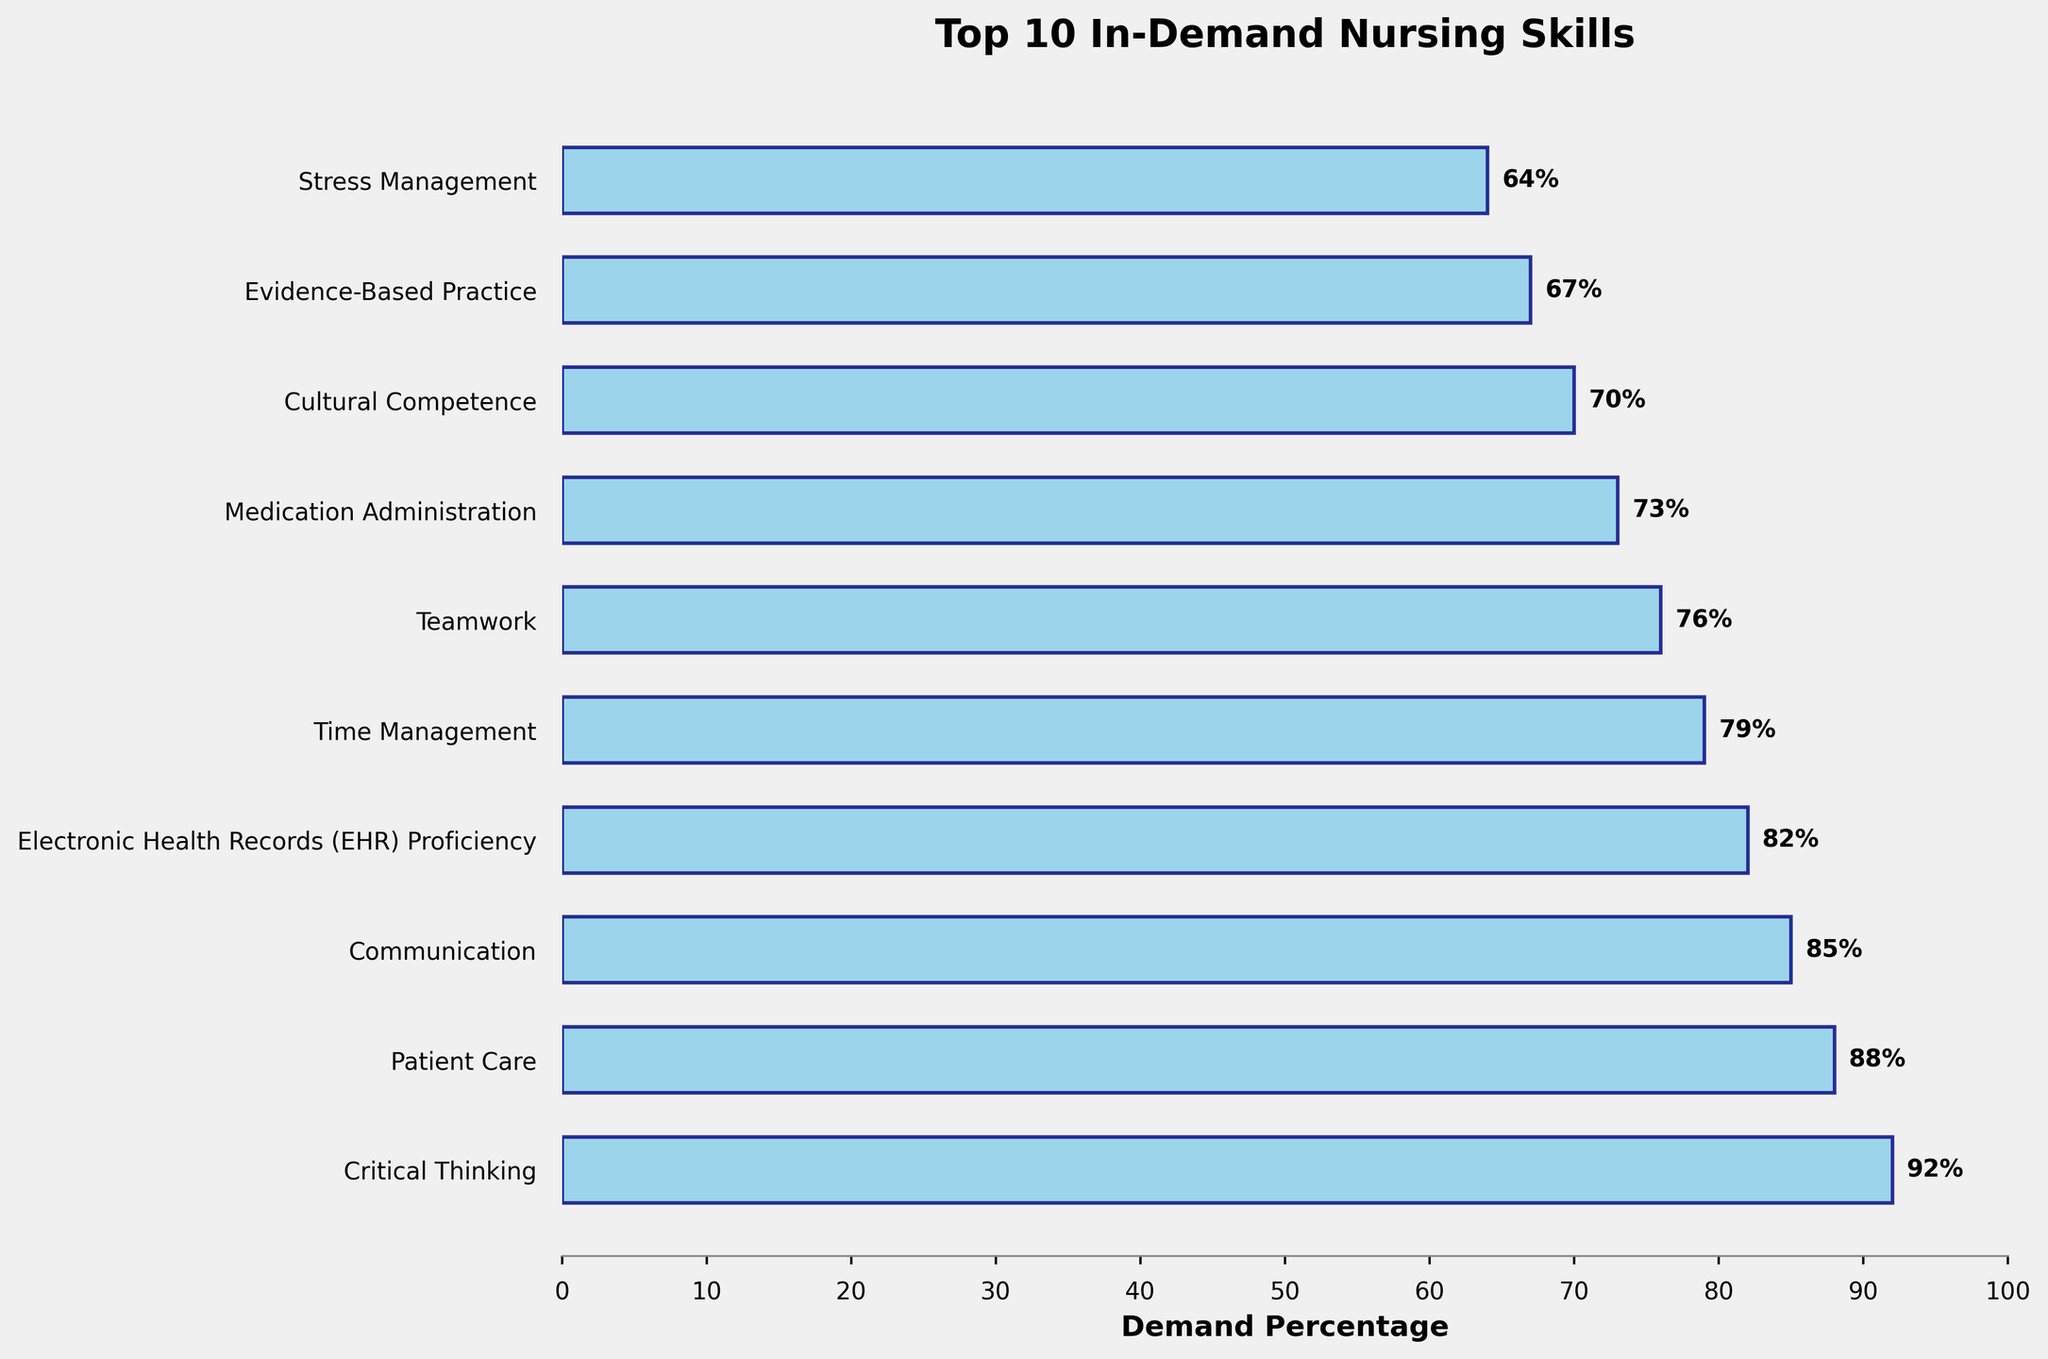what’s the highest demanded nursing skill? Look at the bar chart and find the bar with the highest percentage value. The tallest bar corresponds to the skill with the highest demand percentage. It’s Critical Thinking with 92%.
Answer: Critical Thinking What's the difference in demand percentage between the top two skills? Identify the demand percentages of the top two skills, which are Critical Thinking (92%) and Patient Care (88%). Subtract the smaller percentage from the larger one: 92% - 88% = 4%.
Answer: 4% Which skill has the least demand percentage, and what is it? Look at the bar chart to identify the shortest bar, which represents the skill with the lowest demand percentage. It’s Stress Management with 64%.
Answer: Stress Management What is the sum of the demand percentages for Communication and Teamwork? Identify the demand percentages of Communication (85%) and Teamwork (76%). Add these percentages together: 85% + 76% = 161%.
Answer: 161% How much more in demand is Electronic Health Records (EHR) Proficiency compared to Cultural Competence? Find the demand percentages for Electronic Health Records (82%) and Cultural Competence (70%). Subtract the smaller value from the larger value: 82% - 70% = 12%.
Answer: 12% What's the median demand percentage of the listed nursing skills? Order the demand percentages: 64%, 67%, 70%, 73%, 76%, 79%, 82%, 85%, 88%, 92%. The median is the average of the 5th and 6th values: (76% + 79%) / 2 = 77.5%.
Answer: 77.5% Are there more skills with a demand percentage above or below 80%? Count the bars above and below 80%. Skills above 80%: 4 skills (Critical Thinking, Patient Care, Communication, EHR Proficiency). Skills below 80%: 6 skills (Time Management, Teamwork, Medication Administration, Cultural Competence, Evidence-Based Practice, Stress Management). Therefore, more skills are below 80%.
Answer: Below 80% Which skill has a demand percentage closest to 75%? Look at the bar chart and identify the skill with a demand percentage closest to 75%. Teamwork has a demand percentage of 76%, which is closest to 75%.
Answer: Teamwork How many skills have a demand percentage of 70% or higher? Count the bars that are at or above 70% in the bar chart. There are 8 skills with a demand percentage of 70% or higher.
Answer: 8 What is the average demand percentage for the top 5 skills? Identify the top 5 skills: Critical Thinking (92%), Patient Care (88%), Communication (85%), EHR Proficiency (82%), Time Management (79%). Add these percentages and divide by 5: (92% + 88% + 85% + 82% + 79%) / 5 = 85.2%.
Answer: 85.2% 